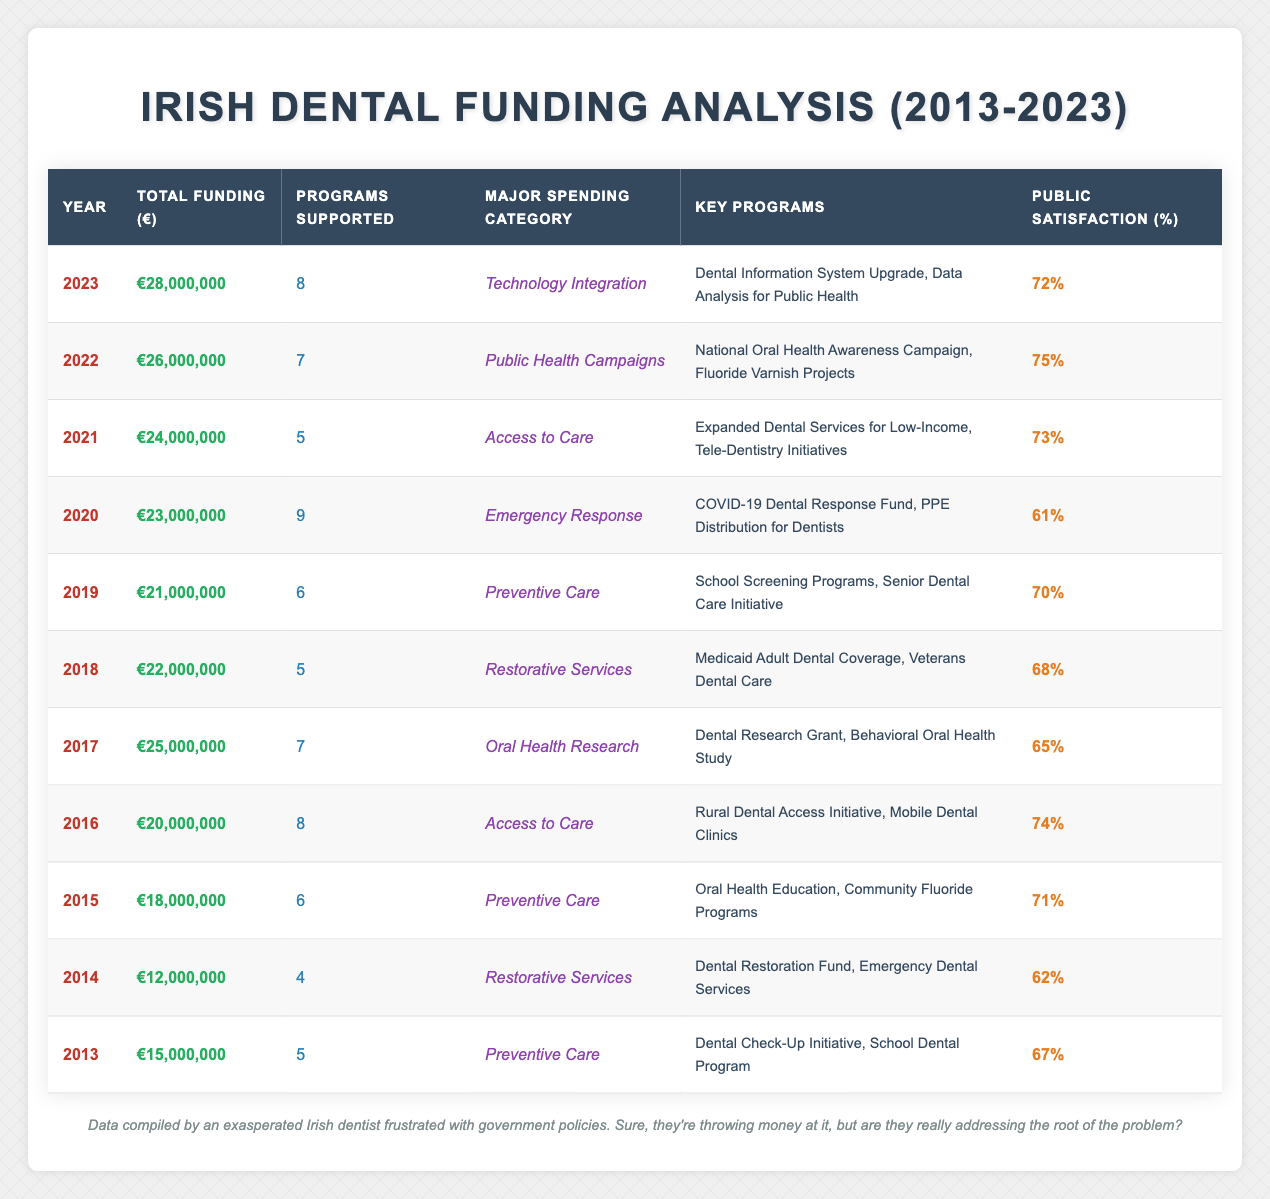What was the total funding allocated in 2020? The total funding allocated in 2020 is listed directly in the table under the "Total Funding (€)" column for that year. It states €23,000,000.
Answer: €23,000,000 Which year had the highest public satisfaction rating? By examining the "Public Satisfaction (%)" column, I find that 2022 has the highest rating at 75%.
Answer: 2022 What is the average total funding allocated for the years 2013 to 2015? The total funding for these years are: €15,000,000 (2013), €12,000,000 (2014), €18,000,000 (2015). Adding these gives €45,000,000, and dividing by 3 gives an average of €15,000,000.
Answer: €15,000,000 Did the funding increase every year from 2013 to 2023? By reviewing the "Total Funding (€)" column, it shows an overall increase from €15,000,000 in 2013 to €28,000,000 in 2023, though some years had decreases (like 2014 compared to 2013). Hence, it did not increase every year.
Answer: No What was the major spending category for the year with the lowest funding? The year with the lowest funding is 2014, which allocated €12,000,000. The corresponding major spending category for that year is "Restorative Services."
Answer: Restorative Services Which two years had the same number of programs supported? By checking the "Programs Supported" column, I see that both 2015 and 2018 supported 6 programs.
Answer: 2015 and 2018 Was the public satisfaction rating consistently above 70% in the last five years? Looking at the "Public Satisfaction (%)" column for the last five years (2019 to 2023), I observe 70%, 68%, 73%, 75%, and 72%. Two years (2019 and 2018) had ratings below 70%, therefore it was not consistent above 70%.
Answer: No How much more funding was allocated in 2022 compared to 2016? The total funding for 2022 is €26,000,000 and for 2016 it is €20,000,000. The difference is €26,000,000 - €20,000,000 = €6,000,000.
Answer: €6,000,000 What were the key programs supported in the year with the highest funding? The highest funding year is 2023 which allocated €28,000,000. The key programs for that year are "Dental Information System Upgrade" and "Data Analysis for Public Health."
Answer: Dental Information System Upgrade, Data Analysis for Public Health 